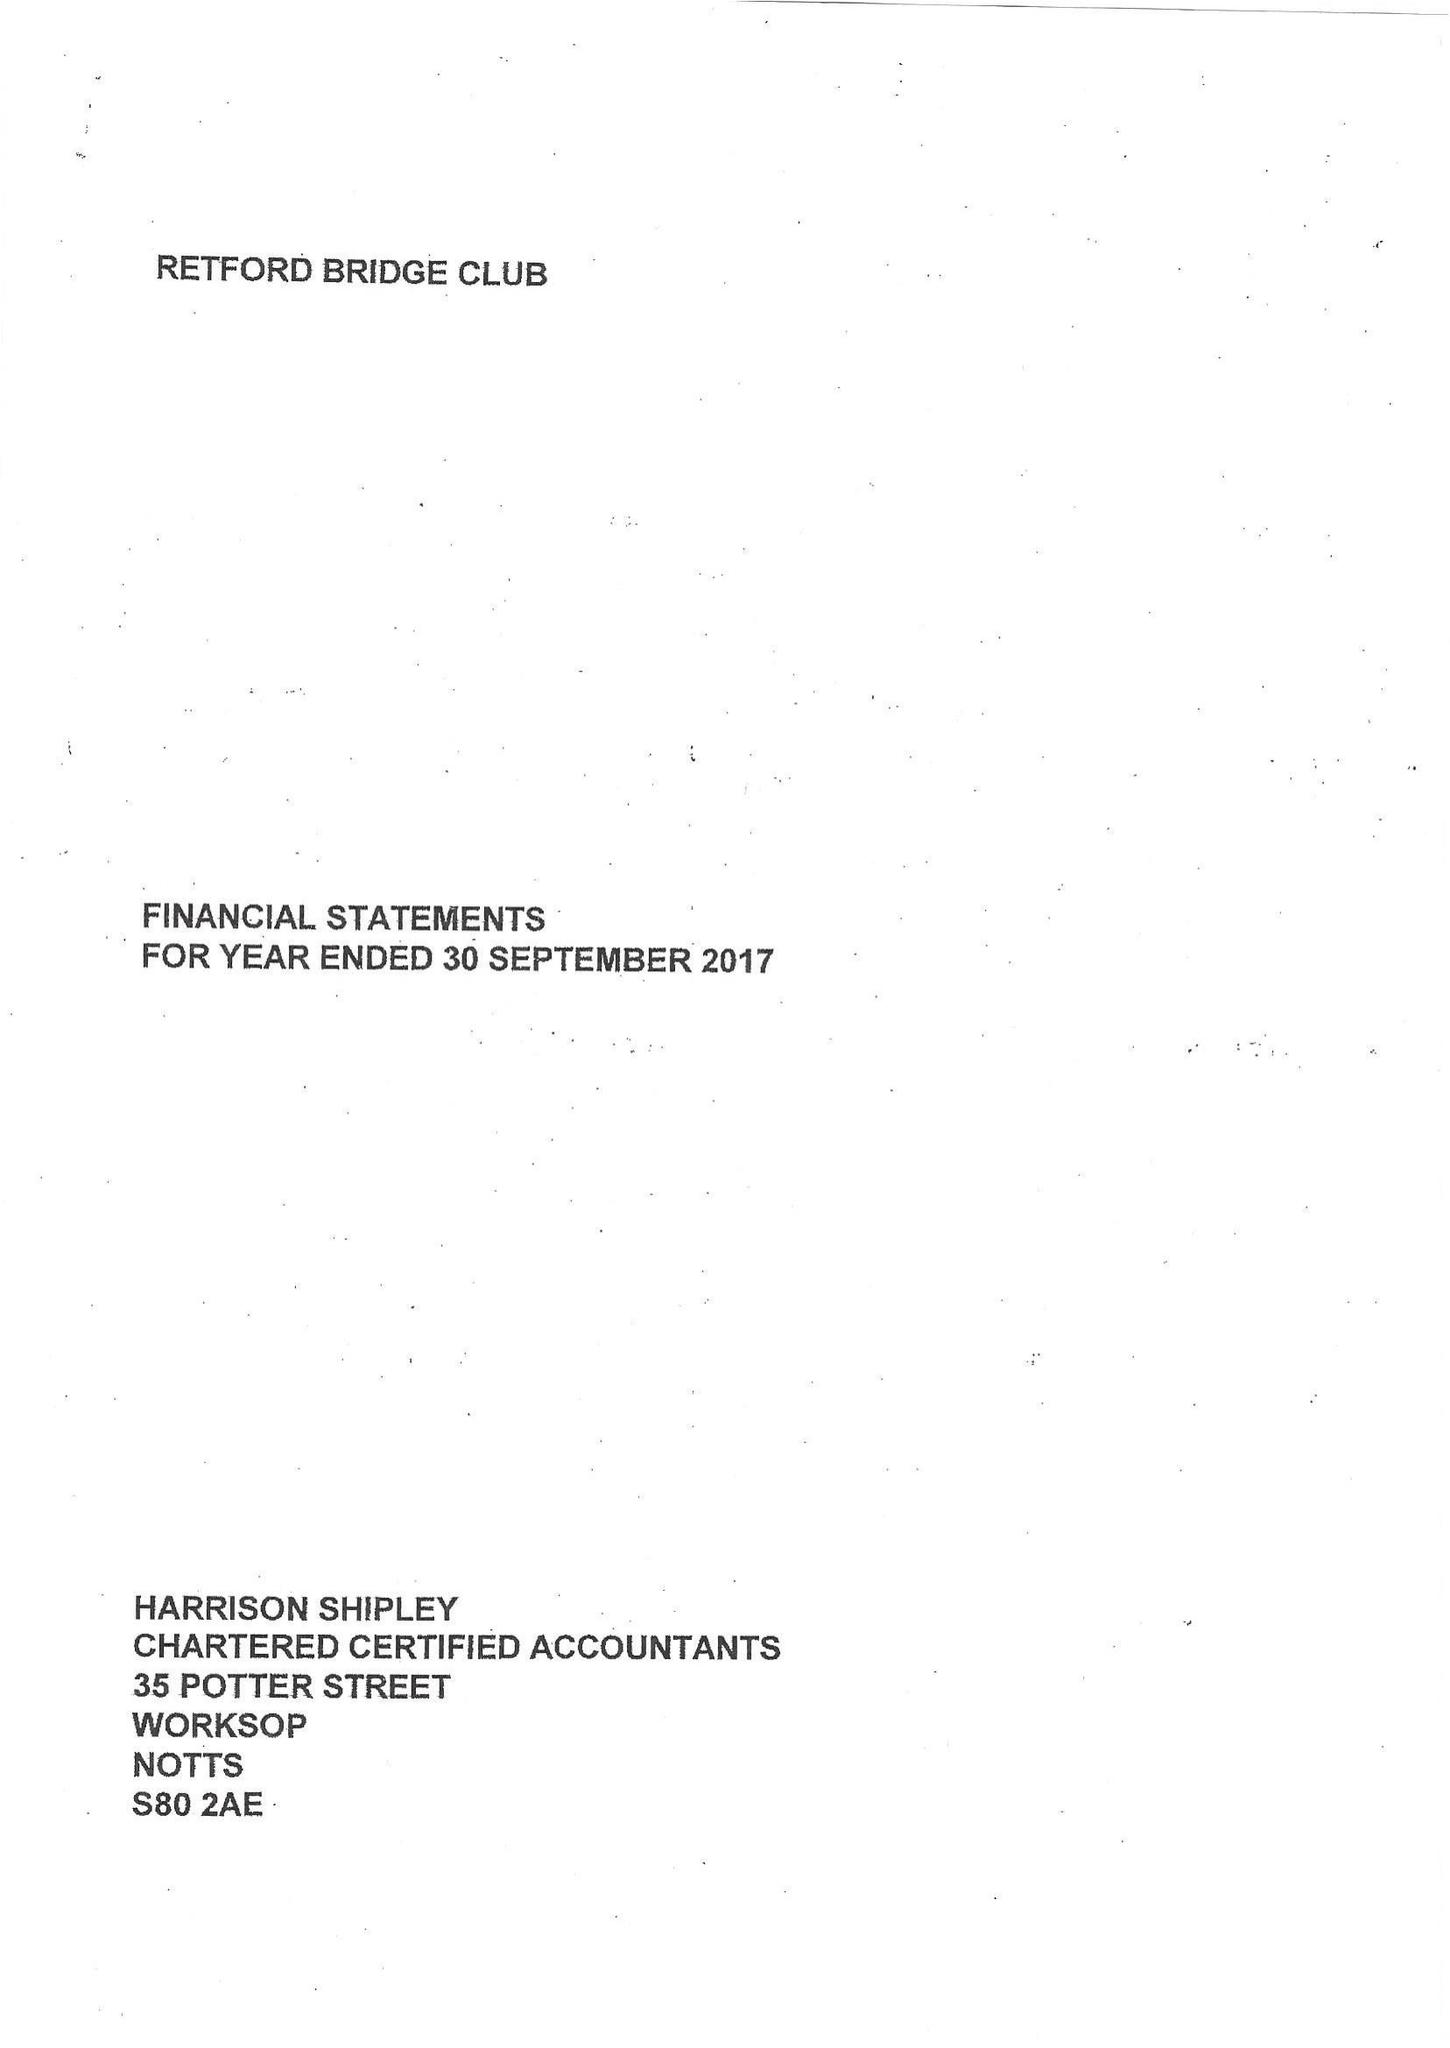What is the value for the address__post_town?
Answer the question using a single word or phrase. WORKSOP 